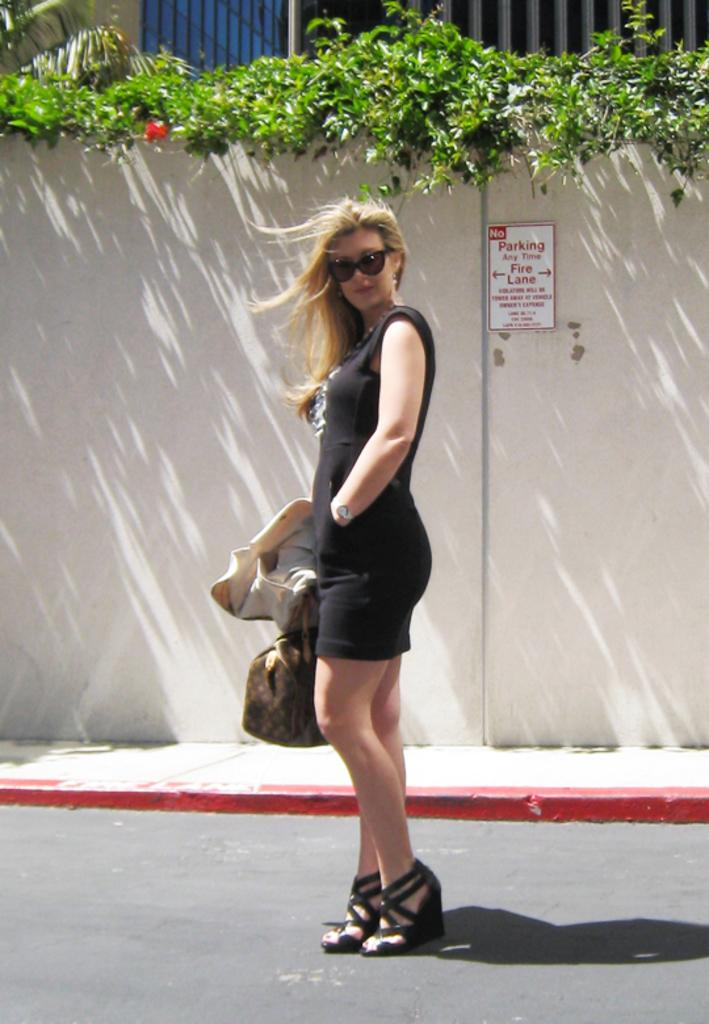Who is present in the image? There is a woman in the image. What is the woman doing in the image? The woman is standing on the road. What is the woman holding in the image? The woman is holding a bag and a coat. What can be seen in the background of the image? There is a wall, plants, and trees visible in the background of the image. What type of volleyball court can be seen in the image? There is no volleyball court present in the image. How low is the woman standing in the image? The height at which the woman is standing cannot be determined from the image alone. 